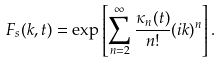<formula> <loc_0><loc_0><loc_500><loc_500>F _ { s } ( k , t ) = \exp \left [ \sum _ { n = 2 } ^ { \infty } \frac { \kappa _ { n } ( t ) } { n ! } ( i k ) ^ { n } \right ] .</formula> 